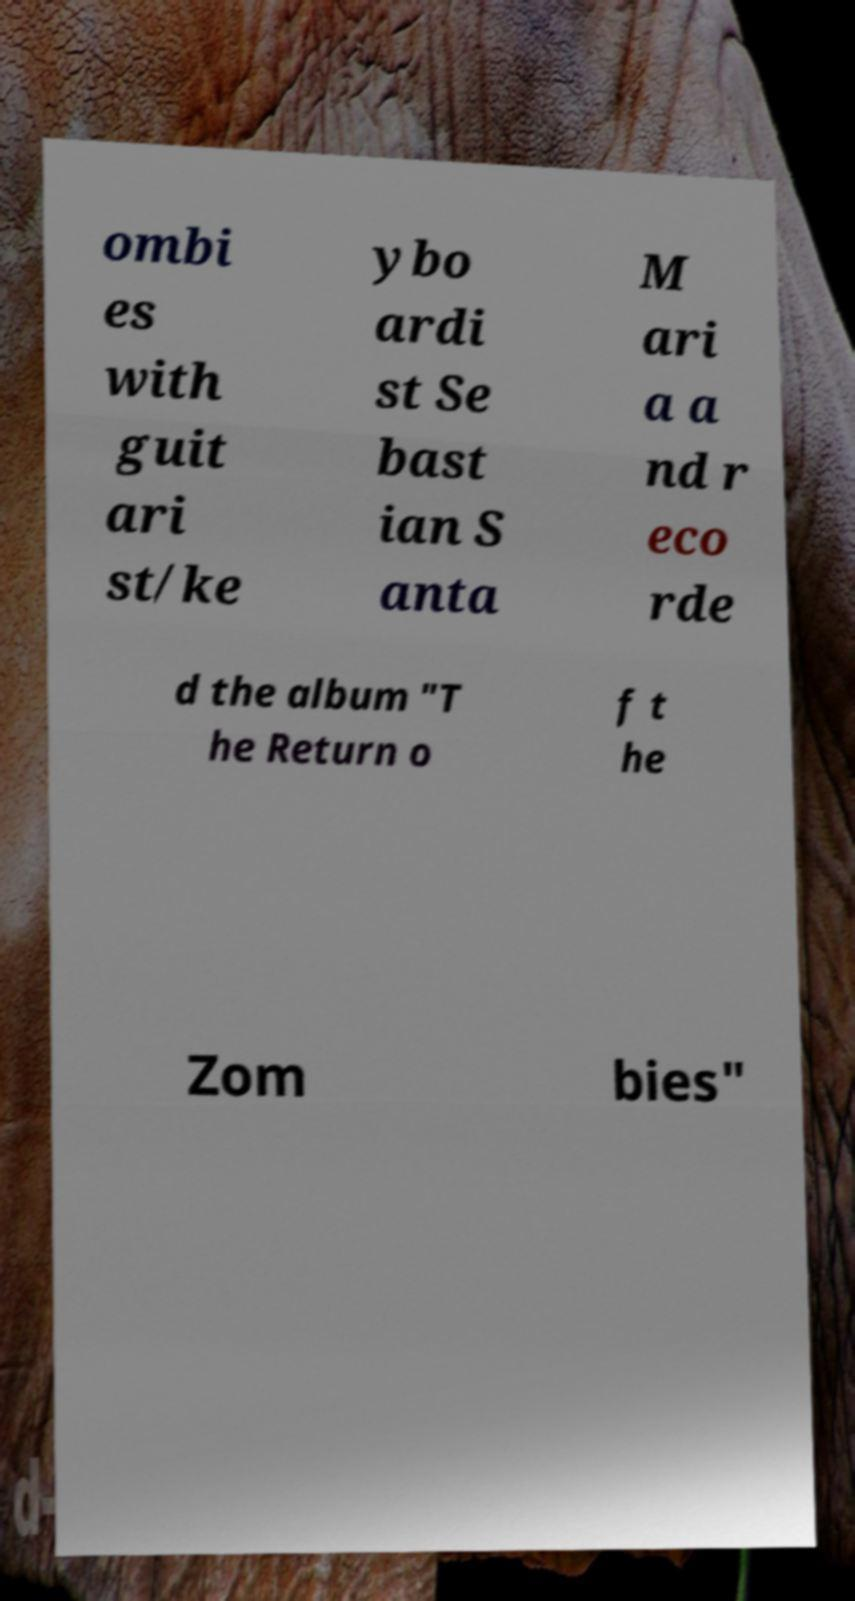Could you assist in decoding the text presented in this image and type it out clearly? ombi es with guit ari st/ke ybo ardi st Se bast ian S anta M ari a a nd r eco rde d the album "T he Return o f t he Zom bies" 